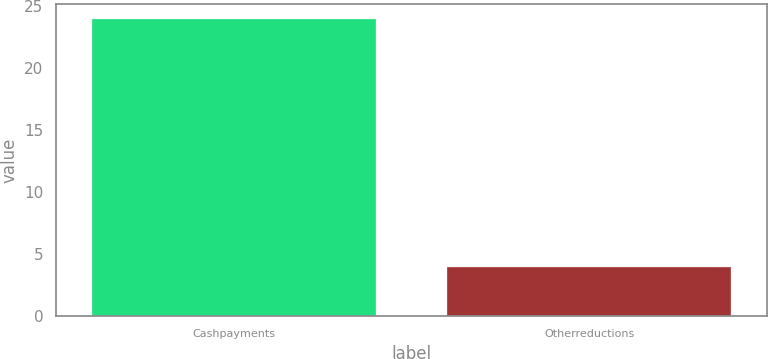Convert chart. <chart><loc_0><loc_0><loc_500><loc_500><bar_chart><fcel>Cashpayments<fcel>Otherreductions<nl><fcel>24<fcel>4<nl></chart> 